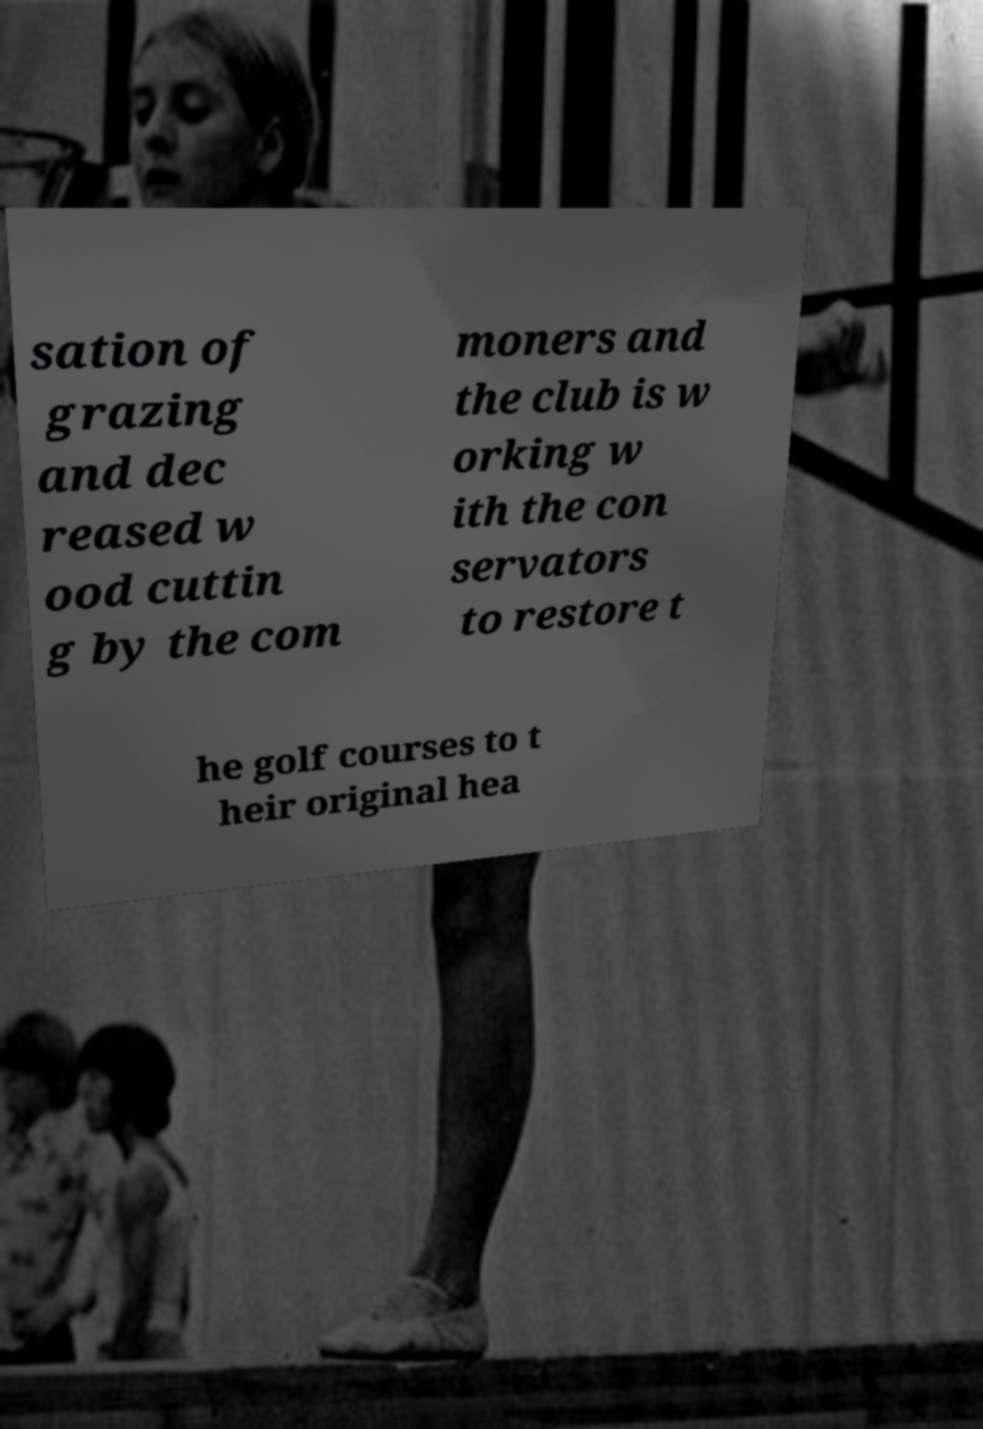Please identify and transcribe the text found in this image. sation of grazing and dec reased w ood cuttin g by the com moners and the club is w orking w ith the con servators to restore t he golf courses to t heir original hea 